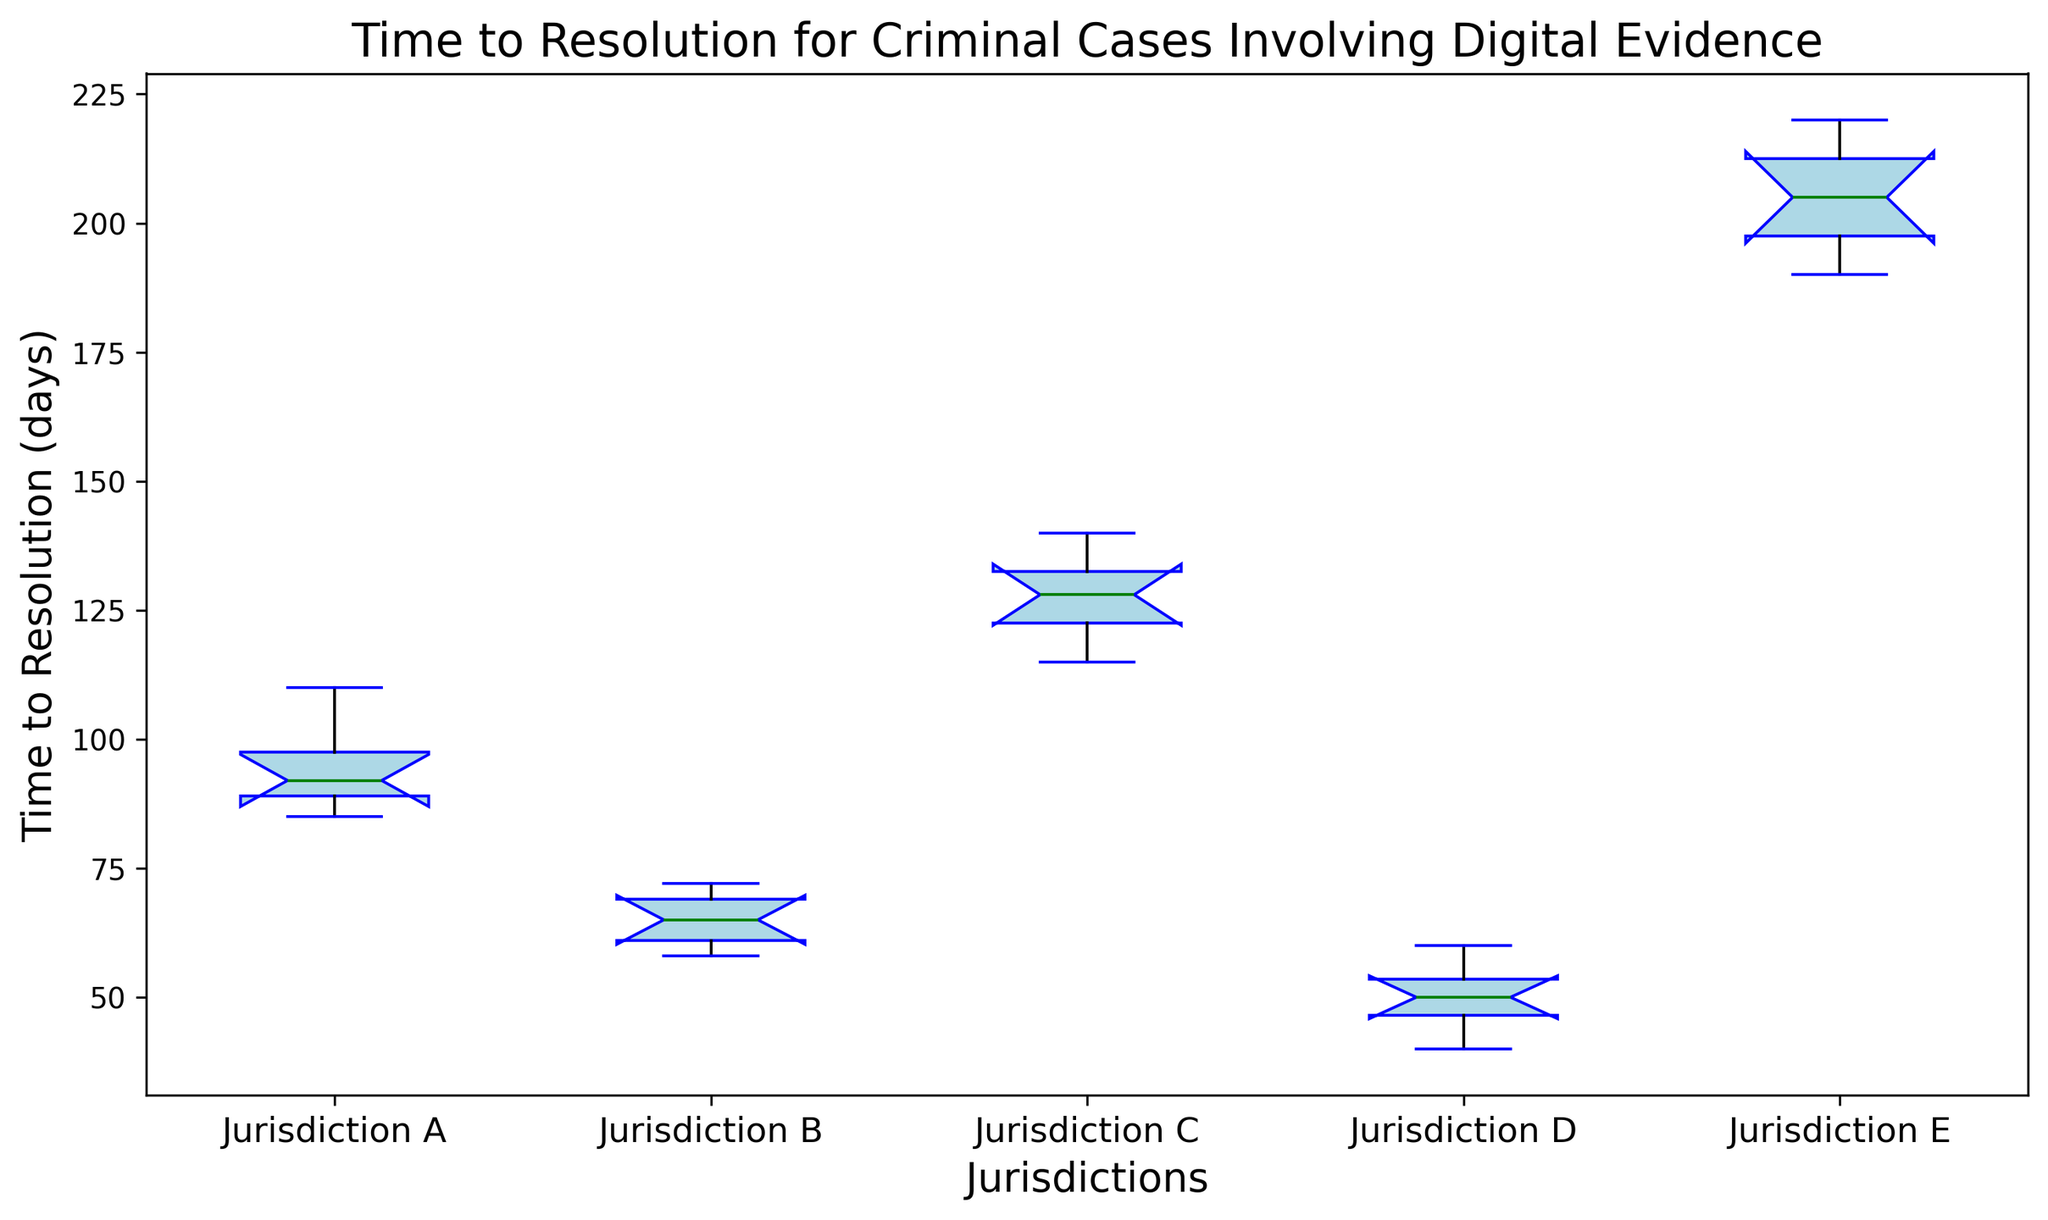What is the median time to resolution for Jurisdiction D? Looking at the box for Jurisdiction D, the thick green line inside the box indicates the median.
Answer: 50 Which jurisdiction has the shortest time to resolution? Look at the lowest point of the whiskers for each box. Jurisdiction D has the lowest value.
Answer: Jurisdiction D What is the range of time to resolution in Jurisdiction E? The range is the difference between the maximum and minimum values, which can be found at the ends of the whiskers for Jurisdiction E. The values are 220 and 190 respectively. Therefore, the range is 220 - 190.
Answer: 30 Which jurisdiction has the widest interquartile range (IQR)? The IQR is the width of the box (the distance between the bottom and top edges). Jurisdiction E has the widest box, indicating the largest IQR.
Answer: Jurisdiction E Between Jurisdiction A and Jurisdiction B, which has the higher median time to resolution? Compare the green median lines of Jurisdiction A and Jurisdiction B. Jurisdiction A’s median line is higher.
Answer: Jurisdiction A What is the upper whisker value for Jurisdiction C? The upper whisker is the topmost horizontal line extending from the box. For Jurisdiction C, this value is at 140.
Answer: 140 Are there any outliers visible in the plot? Outliers are marked by red circles outside the whiskers. There are no red circles visible in the plot, indicating no outliers.
Answer: No How does the median time to resolution in Jurisdiction A compare with Jurisdiction C? By comparing the heights of the green median lines, Jurisdiction C has a higher median than Jurisdiction A.
Answer: Jurisdiction C What is the difference between the medians of Jurisdiction B and Jurisdiction D? The medians are found by the green lines in each box. Jurisdiction B's median is about 65 and Jurisdiction D's median is about 50. The difference is 65 - 50.
Answer: 15 Which jurisdictions have their maximum values above 200 days? The maximum values are found by the top whiskers of each box. Only Jurisdiction E has its upper whisker above 200 days.
Answer: Jurisdiction E 